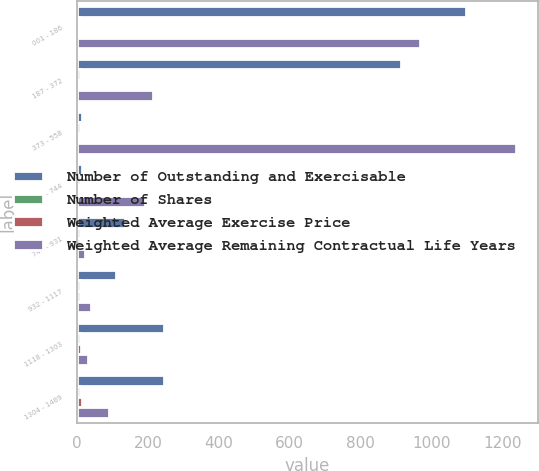Convert chart to OTSL. <chart><loc_0><loc_0><loc_500><loc_500><stacked_bar_chart><ecel><fcel>001 - 186<fcel>187 - 372<fcel>373 - 558<fcel>559 - 744<fcel>745 - 931<fcel>932 - 1117<fcel>1118 - 1303<fcel>1304 - 1489<nl><fcel>Number of Outstanding and Exercisable<fcel>1097<fcel>914<fcel>13.18<fcel>13.18<fcel>137<fcel>109<fcel>246<fcel>245<nl><fcel>Number of Shares<fcel>6.7<fcel>8.7<fcel>8.2<fcel>9.1<fcel>8.7<fcel>8.3<fcel>9.6<fcel>9.7<nl><fcel>Weighted Average Exercise Price<fcel>0.87<fcel>2.66<fcel>4.79<fcel>6.17<fcel>8.02<fcel>10.06<fcel>12.39<fcel>13.97<nl><fcel>Weighted Average Remaining Contractual Life Years<fcel>966<fcel>214<fcel>1236<fcel>191<fcel>24<fcel>40<fcel>32<fcel>92<nl></chart> 